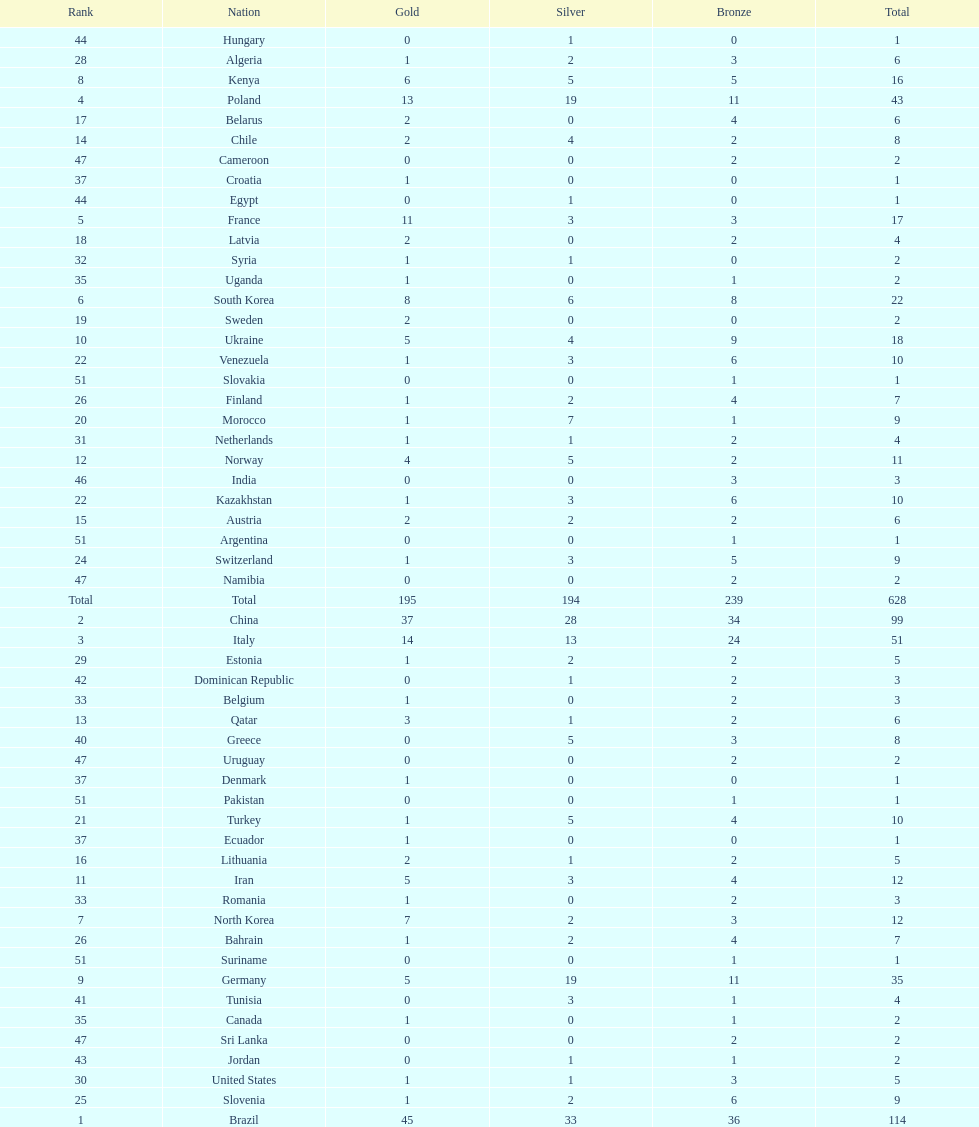How many gold medals did germany earn? 5. 